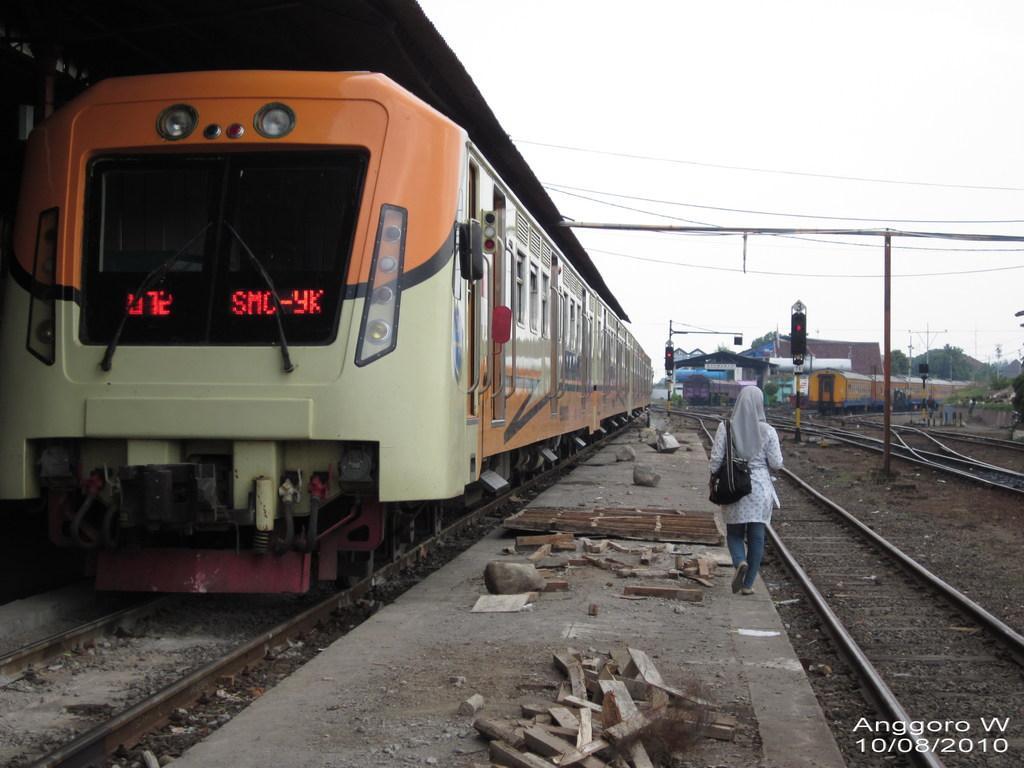Describe this image in one or two sentences. In the picture we can see a train on the railway track and besides it, we can see some path on it, we can see some sticks and rocks and a person walking on it and beside the person we can see some tracks and in the background we can see some signal light, trees and sky. 